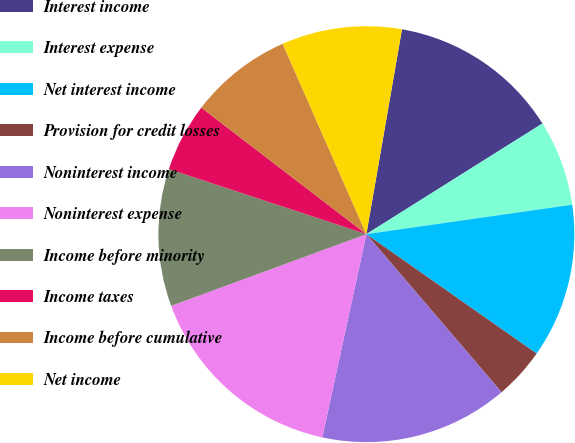Convert chart to OTSL. <chart><loc_0><loc_0><loc_500><loc_500><pie_chart><fcel>Interest income<fcel>Interest expense<fcel>Net interest income<fcel>Provision for credit losses<fcel>Noninterest income<fcel>Noninterest expense<fcel>Income before minority<fcel>Income taxes<fcel>Income before cumulative<fcel>Net income<nl><fcel>13.33%<fcel>6.67%<fcel>12.0%<fcel>4.0%<fcel>14.66%<fcel>16.0%<fcel>10.67%<fcel>5.34%<fcel>8.0%<fcel>9.33%<nl></chart> 